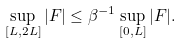Convert formula to latex. <formula><loc_0><loc_0><loc_500><loc_500>\sup _ { [ L , 2 L ] } | F | \leq \beta ^ { - 1 } \sup _ { [ 0 , L ] } | F | .</formula> 